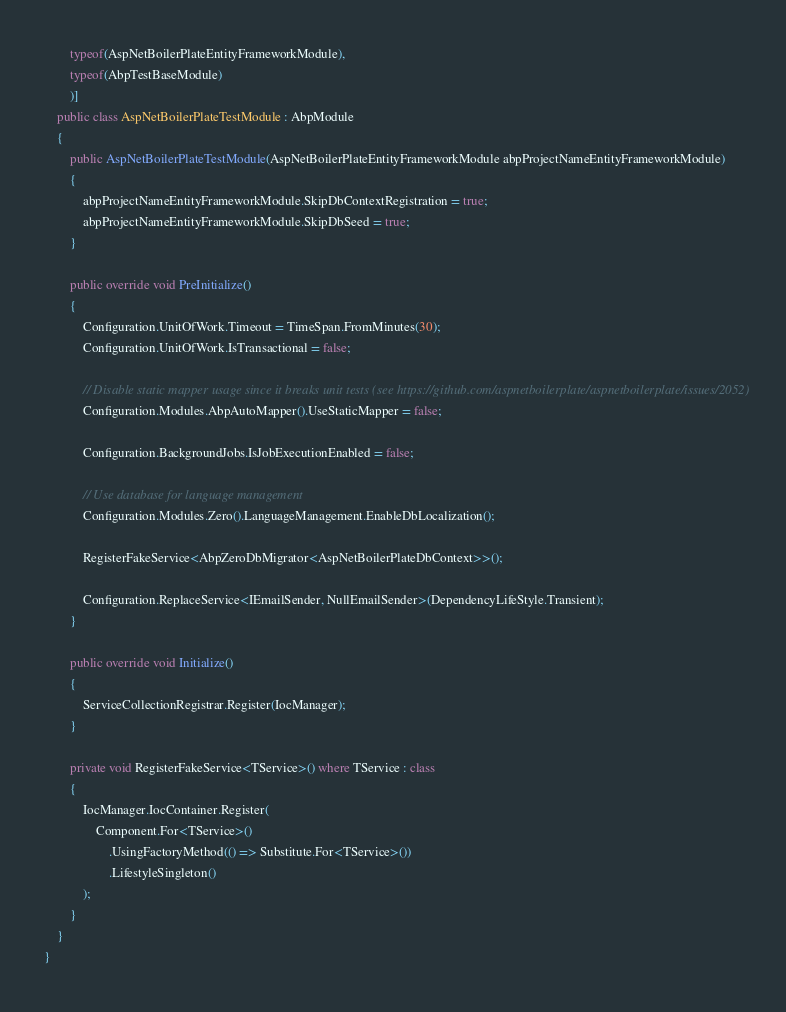<code> <loc_0><loc_0><loc_500><loc_500><_C#_>        typeof(AspNetBoilerPlateEntityFrameworkModule),
        typeof(AbpTestBaseModule)
        )]
    public class AspNetBoilerPlateTestModule : AbpModule
    {
        public AspNetBoilerPlateTestModule(AspNetBoilerPlateEntityFrameworkModule abpProjectNameEntityFrameworkModule)
        {
            abpProjectNameEntityFrameworkModule.SkipDbContextRegistration = true;
            abpProjectNameEntityFrameworkModule.SkipDbSeed = true;
        }

        public override void PreInitialize()
        {
            Configuration.UnitOfWork.Timeout = TimeSpan.FromMinutes(30);
            Configuration.UnitOfWork.IsTransactional = false;

            // Disable static mapper usage since it breaks unit tests (see https://github.com/aspnetboilerplate/aspnetboilerplate/issues/2052)
            Configuration.Modules.AbpAutoMapper().UseStaticMapper = false;

            Configuration.BackgroundJobs.IsJobExecutionEnabled = false;

            // Use database for language management
            Configuration.Modules.Zero().LanguageManagement.EnableDbLocalization();

            RegisterFakeService<AbpZeroDbMigrator<AspNetBoilerPlateDbContext>>();

            Configuration.ReplaceService<IEmailSender, NullEmailSender>(DependencyLifeStyle.Transient);
        }

        public override void Initialize()
        {
            ServiceCollectionRegistrar.Register(IocManager);
        }

        private void RegisterFakeService<TService>() where TService : class
        {
            IocManager.IocContainer.Register(
                Component.For<TService>()
                    .UsingFactoryMethod(() => Substitute.For<TService>())
                    .LifestyleSingleton()
            );
        }
    }
}
</code> 